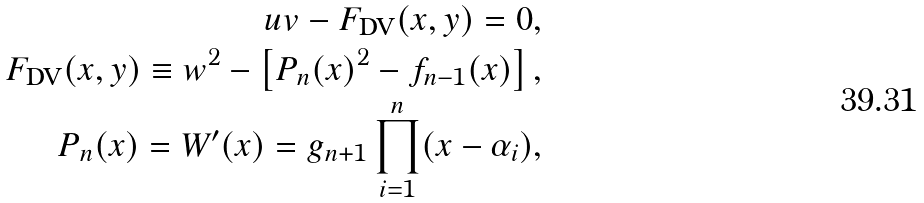Convert formula to latex. <formula><loc_0><loc_0><loc_500><loc_500>u v - F _ { \text {DV} } ( x , y ) = 0 , \\ F _ { \text {DV} } ( x , y ) \equiv w ^ { 2 } - \left [ P _ { n } ( x ) ^ { 2 } - f _ { n - 1 } ( x ) \right ] , \\ P _ { n } ( x ) = W ^ { \prime } ( x ) = g _ { n + 1 } \prod _ { i = 1 } ^ { n } ( x - \alpha _ { i } ) ,</formula> 